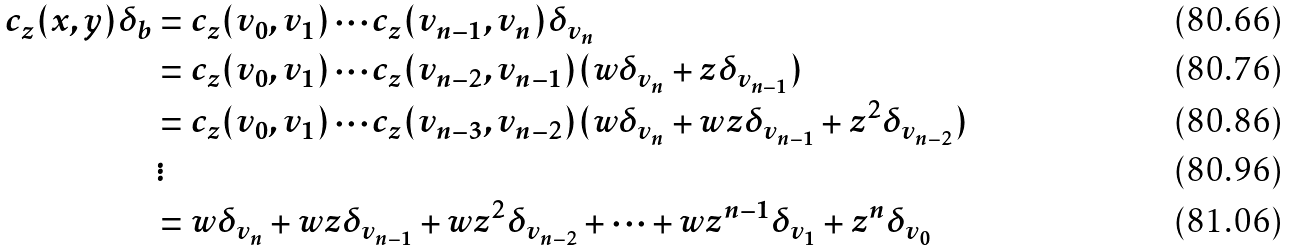<formula> <loc_0><loc_0><loc_500><loc_500>c _ { z } ( x , y ) \delta _ { b } & = c _ { z } ( v _ { 0 } , v _ { 1 } ) \cdots c _ { z } ( v _ { n - 1 } , v _ { n } ) \delta _ { v _ { n } } \\ & = c _ { z } ( v _ { 0 } , v _ { 1 } ) \cdots c _ { z } ( v _ { n - 2 } , v _ { n - 1 } ) ( w \delta _ { v _ { n } } + z \delta _ { v _ { n - 1 } } ) \\ & = c _ { z } ( v _ { 0 } , v _ { 1 } ) \cdots c _ { z } ( v _ { n - 3 } , v _ { n - 2 } ) ( w \delta _ { v _ { n } } + w z \delta _ { v _ { n - 1 } } + z ^ { 2 } \delta _ { v _ { n - 2 } } ) \\ & \, \vdots \\ & = w \delta _ { v _ { n } } + w z \delta _ { v _ { n - 1 } } + w z ^ { 2 } \delta _ { v _ { n - 2 } } + \cdots + w z ^ { n - 1 } \delta _ { v _ { 1 } } + z ^ { n } \delta _ { v _ { 0 } }</formula> 